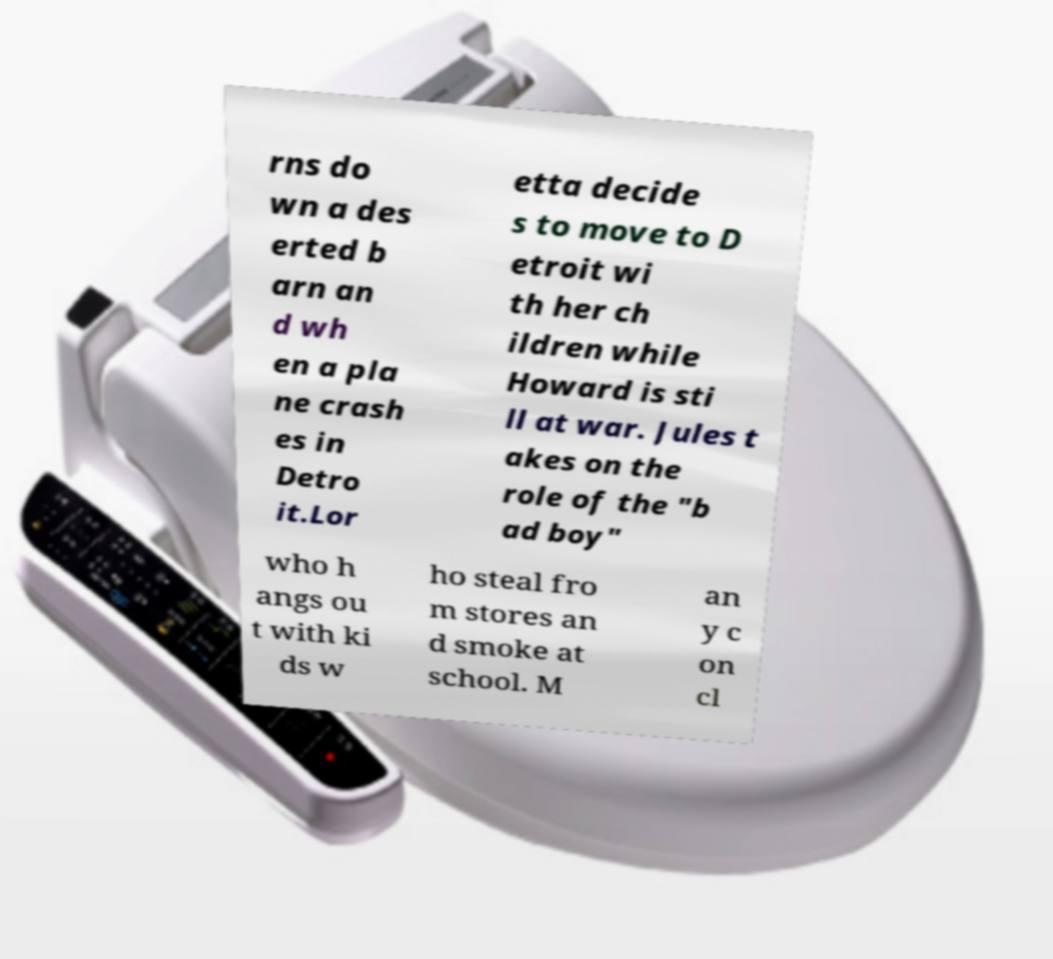Please read and relay the text visible in this image. What does it say? rns do wn a des erted b arn an d wh en a pla ne crash es in Detro it.Lor etta decide s to move to D etroit wi th her ch ildren while Howard is sti ll at war. Jules t akes on the role of the "b ad boy" who h angs ou t with ki ds w ho steal fro m stores an d smoke at school. M an y c on cl 